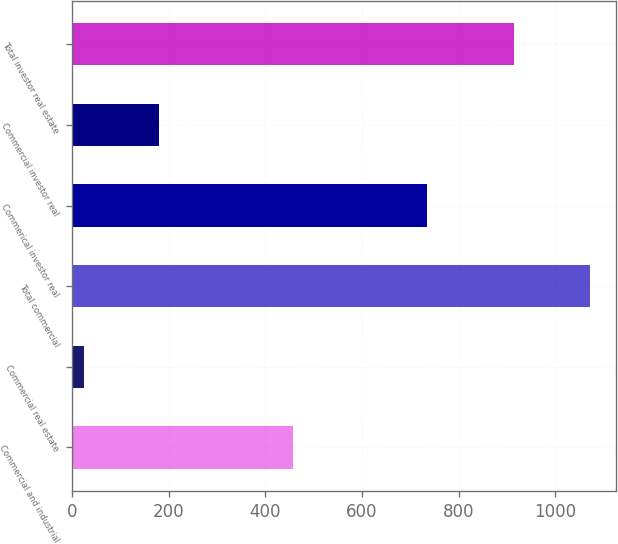<chart> <loc_0><loc_0><loc_500><loc_500><bar_chart><fcel>Commercial and industrial<fcel>Commercial real estate<fcel>Total commercial<fcel>Commerical investor real<fcel>Commercial investor real<fcel>Total investor real estate<nl><fcel>457<fcel>25<fcel>1072<fcel>734<fcel>180<fcel>914<nl></chart> 